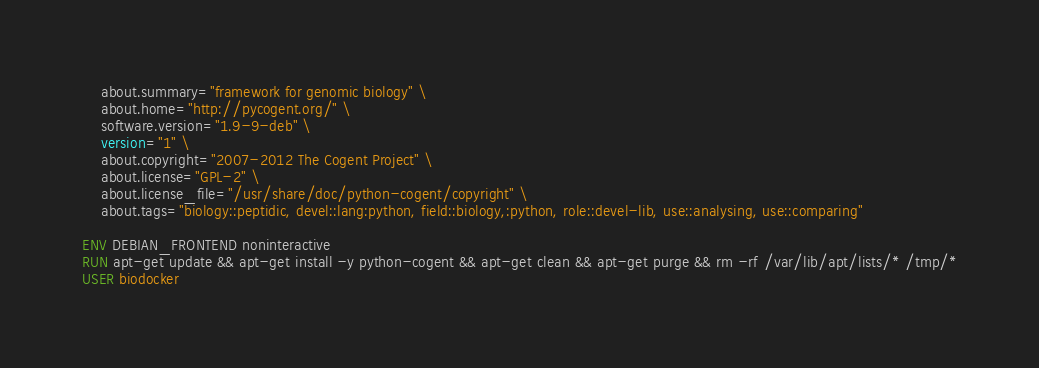<code> <loc_0><loc_0><loc_500><loc_500><_Dockerfile_>    about.summary="framework for genomic biology" \ 
    about.home="http://pycogent.org/" \ 
    software.version="1.9-9-deb" \ 
    version="1" \ 
    about.copyright="2007-2012 The Cogent Project" \ 
    about.license="GPL-2" \ 
    about.license_file="/usr/share/doc/python-cogent/copyright" \ 
    about.tags="biology::peptidic, devel::lang:python, field::biology,:python, role::devel-lib, use::analysing, use::comparing" 

ENV DEBIAN_FRONTEND noninteractive
RUN apt-get update && apt-get install -y python-cogent && apt-get clean && apt-get purge && rm -rf /var/lib/apt/lists/* /tmp/*
USER biodocker
</code> 